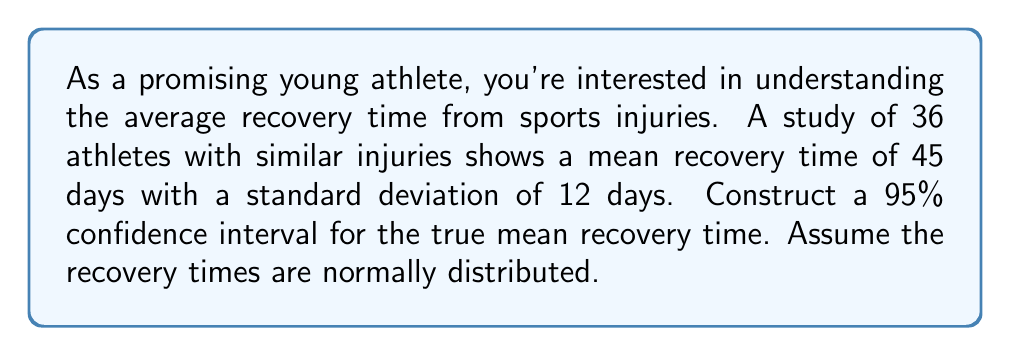Give your solution to this math problem. To construct a 95% confidence interval for the mean, we'll use the formula:

$$\bar{x} \pm t_{\alpha/2} \cdot \frac{s}{\sqrt{n}}$$

Where:
$\bar{x}$ = sample mean
$t_{\alpha/2}$ = t-value for 95% confidence level with n-1 degrees of freedom
$s$ = sample standard deviation
$n$ = sample size

Step 1: Identify the known values
$\bar{x} = 45$ days
$s = 12$ days
$n = 36$
Confidence level = 95% (α = 0.05)

Step 2: Find the t-value
Degrees of freedom = n - 1 = 36 - 1 = 35
For a 95% confidence interval with 35 degrees of freedom, $t_{\alpha/2} = 2.030$ (from t-distribution table)

Step 3: Calculate the margin of error
$$\text{Margin of Error} = t_{\alpha/2} \cdot \frac{s}{\sqrt{n}} = 2.030 \cdot \frac{12}{\sqrt{36}} = 2.030 \cdot 2 = 4.06$$

Step 4: Calculate the confidence interval
Lower bound: $45 - 4.06 = 40.94$
Upper bound: $45 + 4.06 = 49.06$

Therefore, the 95% confidence interval for the true mean recovery time is (40.94, 49.06) days.
Answer: (40.94, 49.06) days 